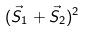Convert formula to latex. <formula><loc_0><loc_0><loc_500><loc_500>( \vec { S } _ { 1 } + \vec { S } _ { 2 } ) ^ { 2 }</formula> 